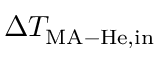Convert formula to latex. <formula><loc_0><loc_0><loc_500><loc_500>\Delta T _ { M A - H e , i n }</formula> 